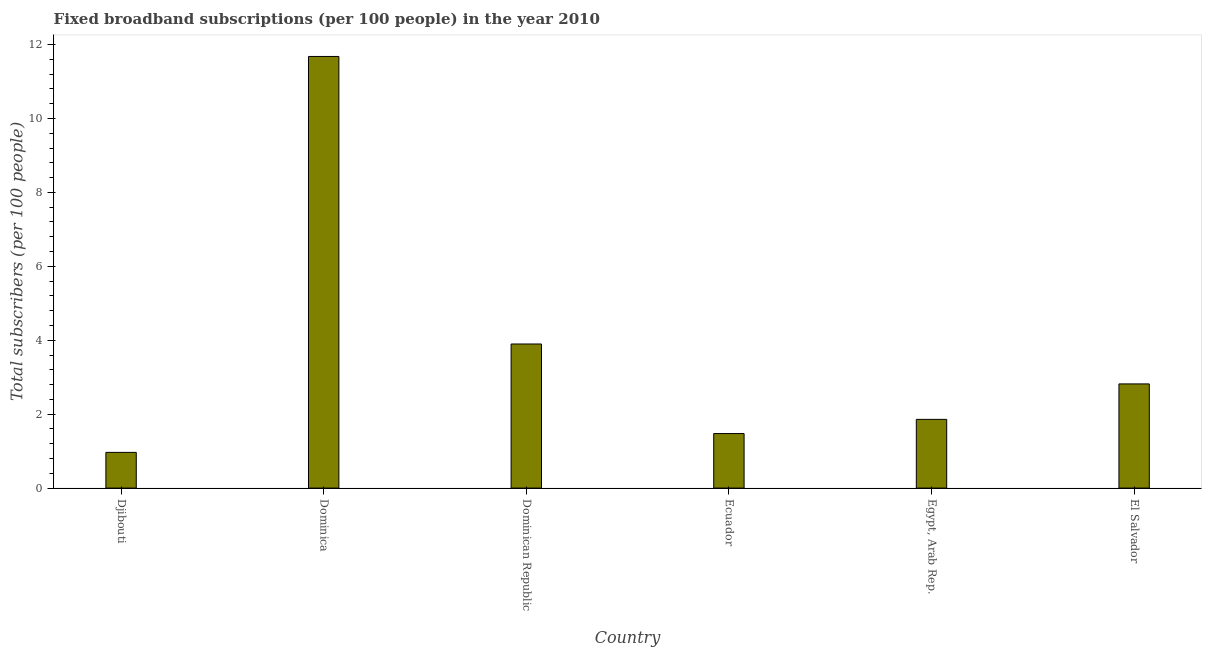Does the graph contain grids?
Provide a short and direct response. No. What is the title of the graph?
Offer a terse response. Fixed broadband subscriptions (per 100 people) in the year 2010. What is the label or title of the X-axis?
Ensure brevity in your answer.  Country. What is the label or title of the Y-axis?
Your answer should be compact. Total subscribers (per 100 people). What is the total number of fixed broadband subscriptions in Dominica?
Make the answer very short. 11.68. Across all countries, what is the maximum total number of fixed broadband subscriptions?
Offer a terse response. 11.68. Across all countries, what is the minimum total number of fixed broadband subscriptions?
Your answer should be compact. 0.97. In which country was the total number of fixed broadband subscriptions maximum?
Make the answer very short. Dominica. In which country was the total number of fixed broadband subscriptions minimum?
Give a very brief answer. Djibouti. What is the sum of the total number of fixed broadband subscriptions?
Your answer should be very brief. 22.7. What is the difference between the total number of fixed broadband subscriptions in Dominica and Egypt, Arab Rep.?
Provide a short and direct response. 9.82. What is the average total number of fixed broadband subscriptions per country?
Make the answer very short. 3.78. What is the median total number of fixed broadband subscriptions?
Ensure brevity in your answer.  2.34. In how many countries, is the total number of fixed broadband subscriptions greater than 2.4 ?
Your answer should be compact. 3. What is the ratio of the total number of fixed broadband subscriptions in Djibouti to that in Dominica?
Provide a succinct answer. 0.08. What is the difference between the highest and the second highest total number of fixed broadband subscriptions?
Keep it short and to the point. 7.78. What is the difference between the highest and the lowest total number of fixed broadband subscriptions?
Provide a short and direct response. 10.71. Are all the bars in the graph horizontal?
Offer a very short reply. No. What is the difference between two consecutive major ticks on the Y-axis?
Ensure brevity in your answer.  2. What is the Total subscribers (per 100 people) of Djibouti?
Your answer should be compact. 0.97. What is the Total subscribers (per 100 people) of Dominica?
Provide a short and direct response. 11.68. What is the Total subscribers (per 100 people) of Dominican Republic?
Your answer should be compact. 3.9. What is the Total subscribers (per 100 people) in Ecuador?
Provide a succinct answer. 1.48. What is the Total subscribers (per 100 people) in Egypt, Arab Rep.?
Your response must be concise. 1.86. What is the Total subscribers (per 100 people) in El Salvador?
Ensure brevity in your answer.  2.82. What is the difference between the Total subscribers (per 100 people) in Djibouti and Dominica?
Make the answer very short. -10.71. What is the difference between the Total subscribers (per 100 people) in Djibouti and Dominican Republic?
Provide a succinct answer. -2.93. What is the difference between the Total subscribers (per 100 people) in Djibouti and Ecuador?
Keep it short and to the point. -0.51. What is the difference between the Total subscribers (per 100 people) in Djibouti and Egypt, Arab Rep.?
Keep it short and to the point. -0.89. What is the difference between the Total subscribers (per 100 people) in Djibouti and El Salvador?
Ensure brevity in your answer.  -1.85. What is the difference between the Total subscribers (per 100 people) in Dominica and Dominican Republic?
Keep it short and to the point. 7.78. What is the difference between the Total subscribers (per 100 people) in Dominica and Ecuador?
Your answer should be compact. 10.2. What is the difference between the Total subscribers (per 100 people) in Dominica and Egypt, Arab Rep.?
Your answer should be compact. 9.82. What is the difference between the Total subscribers (per 100 people) in Dominica and El Salvador?
Keep it short and to the point. 8.86. What is the difference between the Total subscribers (per 100 people) in Dominican Republic and Ecuador?
Provide a short and direct response. 2.42. What is the difference between the Total subscribers (per 100 people) in Dominican Republic and Egypt, Arab Rep.?
Your response must be concise. 2.04. What is the difference between the Total subscribers (per 100 people) in Dominican Republic and El Salvador?
Provide a succinct answer. 1.08. What is the difference between the Total subscribers (per 100 people) in Ecuador and Egypt, Arab Rep.?
Give a very brief answer. -0.38. What is the difference between the Total subscribers (per 100 people) in Ecuador and El Salvador?
Offer a terse response. -1.34. What is the difference between the Total subscribers (per 100 people) in Egypt, Arab Rep. and El Salvador?
Make the answer very short. -0.96. What is the ratio of the Total subscribers (per 100 people) in Djibouti to that in Dominica?
Your answer should be very brief. 0.08. What is the ratio of the Total subscribers (per 100 people) in Djibouti to that in Dominican Republic?
Offer a very short reply. 0.25. What is the ratio of the Total subscribers (per 100 people) in Djibouti to that in Ecuador?
Provide a short and direct response. 0.66. What is the ratio of the Total subscribers (per 100 people) in Djibouti to that in Egypt, Arab Rep.?
Your answer should be very brief. 0.52. What is the ratio of the Total subscribers (per 100 people) in Djibouti to that in El Salvador?
Make the answer very short. 0.34. What is the ratio of the Total subscribers (per 100 people) in Dominica to that in Dominican Republic?
Keep it short and to the point. 3. What is the ratio of the Total subscribers (per 100 people) in Dominica to that in Ecuador?
Offer a very short reply. 7.92. What is the ratio of the Total subscribers (per 100 people) in Dominica to that in Egypt, Arab Rep.?
Offer a terse response. 6.28. What is the ratio of the Total subscribers (per 100 people) in Dominica to that in El Salvador?
Provide a succinct answer. 4.14. What is the ratio of the Total subscribers (per 100 people) in Dominican Republic to that in Ecuador?
Ensure brevity in your answer.  2.64. What is the ratio of the Total subscribers (per 100 people) in Dominican Republic to that in Egypt, Arab Rep.?
Offer a terse response. 2.1. What is the ratio of the Total subscribers (per 100 people) in Dominican Republic to that in El Salvador?
Your response must be concise. 1.38. What is the ratio of the Total subscribers (per 100 people) in Ecuador to that in Egypt, Arab Rep.?
Make the answer very short. 0.79. What is the ratio of the Total subscribers (per 100 people) in Ecuador to that in El Salvador?
Make the answer very short. 0.52. What is the ratio of the Total subscribers (per 100 people) in Egypt, Arab Rep. to that in El Salvador?
Make the answer very short. 0.66. 